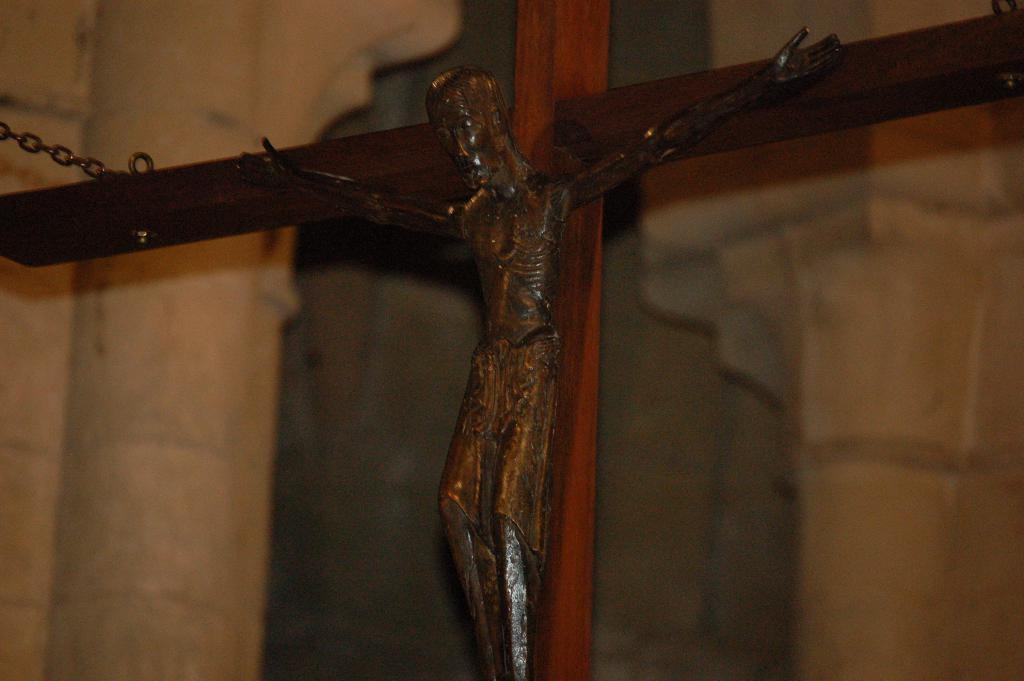What is the main subject of the image? There is a Crucifix in the image. What is depicted on the Crucifix? The Crucifix has an image of Jesus on it. How is the Crucifix displayed in the image? The Crucifix is placed on a cross. What can be seen in the background of the image? There is a white wall in the background of the image. Where might this image have been taken? The image might have been taken in a church. What route does the division take through the houses in the image? There are no houses, routes, or divisions present in the image; it features a Crucifix on a cross. 